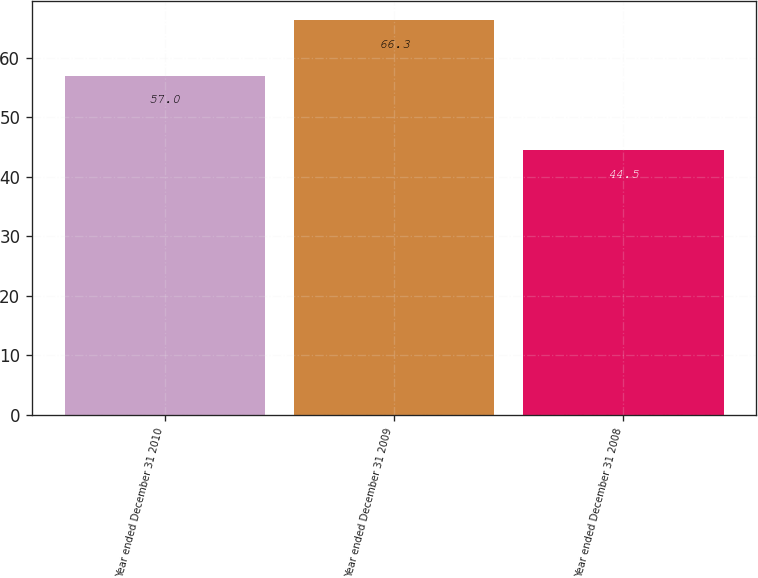Convert chart to OTSL. <chart><loc_0><loc_0><loc_500><loc_500><bar_chart><fcel>Year ended December 31 2010<fcel>Year ended December 31 2009<fcel>Year ended December 31 2008<nl><fcel>57<fcel>66.3<fcel>44.5<nl></chart> 